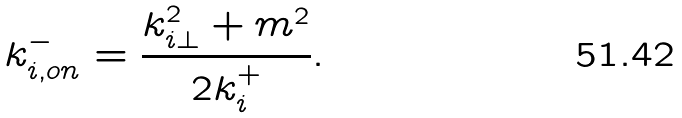<formula> <loc_0><loc_0><loc_500><loc_500>k ^ { - } _ { i , o n } = \frac { k ^ { 2 } _ { i \perp } + m ^ { 2 } } { 2 k ^ { + } _ { i } } .</formula> 